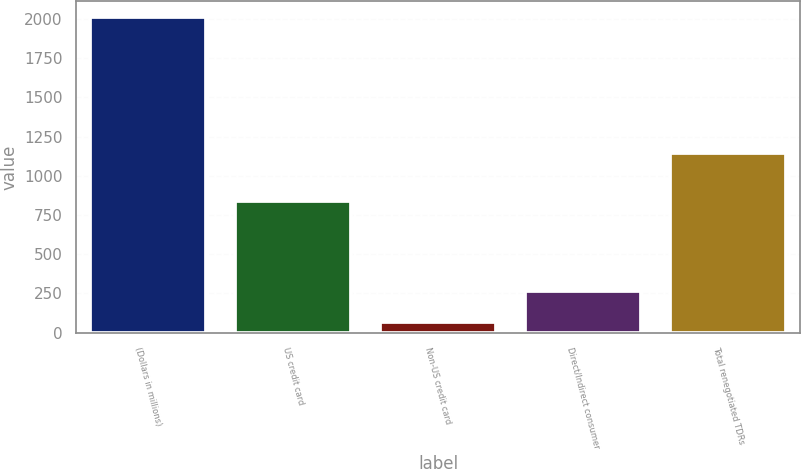<chart> <loc_0><loc_0><loc_500><loc_500><bar_chart><fcel>(Dollars in millions)<fcel>US credit card<fcel>Non-US credit card<fcel>Direct/Indirect consumer<fcel>Total renegotiated TDRs<nl><fcel>2013<fcel>842<fcel>71<fcel>265.2<fcel>1143<nl></chart> 